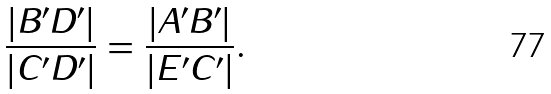Convert formula to latex. <formula><loc_0><loc_0><loc_500><loc_500>\frac { | B ^ { \prime } D ^ { \prime } | } { | C ^ { \prime } D ^ { \prime } | } = \frac { | A ^ { \prime } B ^ { \prime } | } { | E ^ { \prime } C ^ { \prime } | } .</formula> 